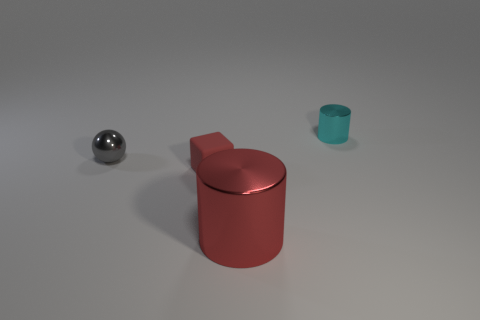Is the size of the ball the same as the cube? Upon observation, the ball appears to be smaller in size compared to the cube. It's essential to note that appearance can be deceptive without exact measurements, but the ball's diameter seems less than the cube's edge length visually. 